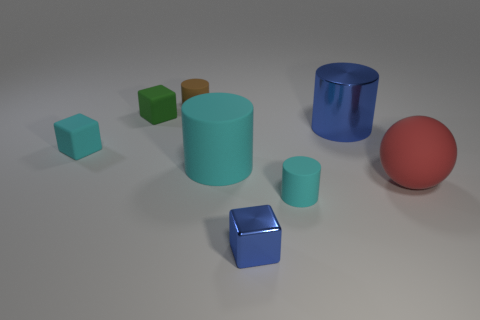Subtract all shiny cylinders. How many cylinders are left? 3 Add 1 rubber blocks. How many objects exist? 9 Subtract all green cubes. How many cyan cylinders are left? 2 Subtract all cyan cylinders. How many cylinders are left? 2 Subtract all cubes. How many objects are left? 5 Subtract 3 cylinders. How many cylinders are left? 1 Subtract all green cylinders. Subtract all brown blocks. How many cylinders are left? 4 Subtract all blue objects. Subtract all small blocks. How many objects are left? 3 Add 2 big blue metal objects. How many big blue metal objects are left? 3 Add 8 large cyan blocks. How many large cyan blocks exist? 8 